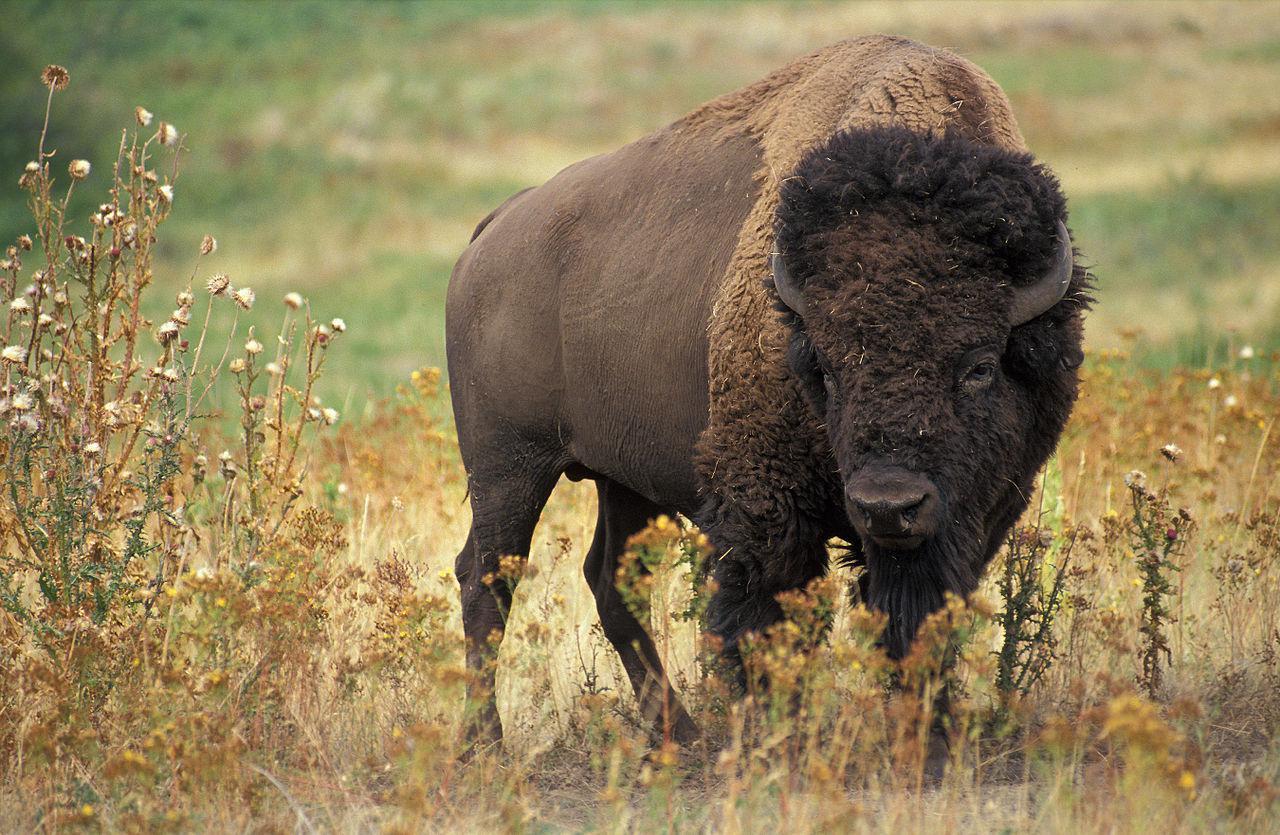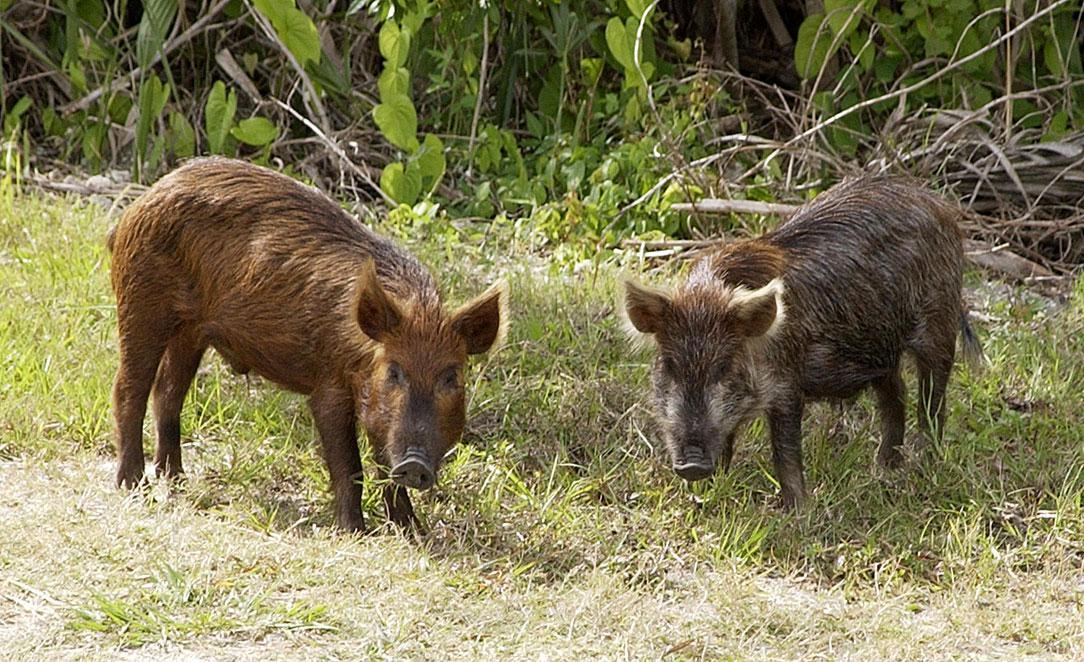The first image is the image on the left, the second image is the image on the right. Evaluate the accuracy of this statement regarding the images: "There is more than one warthog in one of these images.". Is it true? Answer yes or no. Yes. 